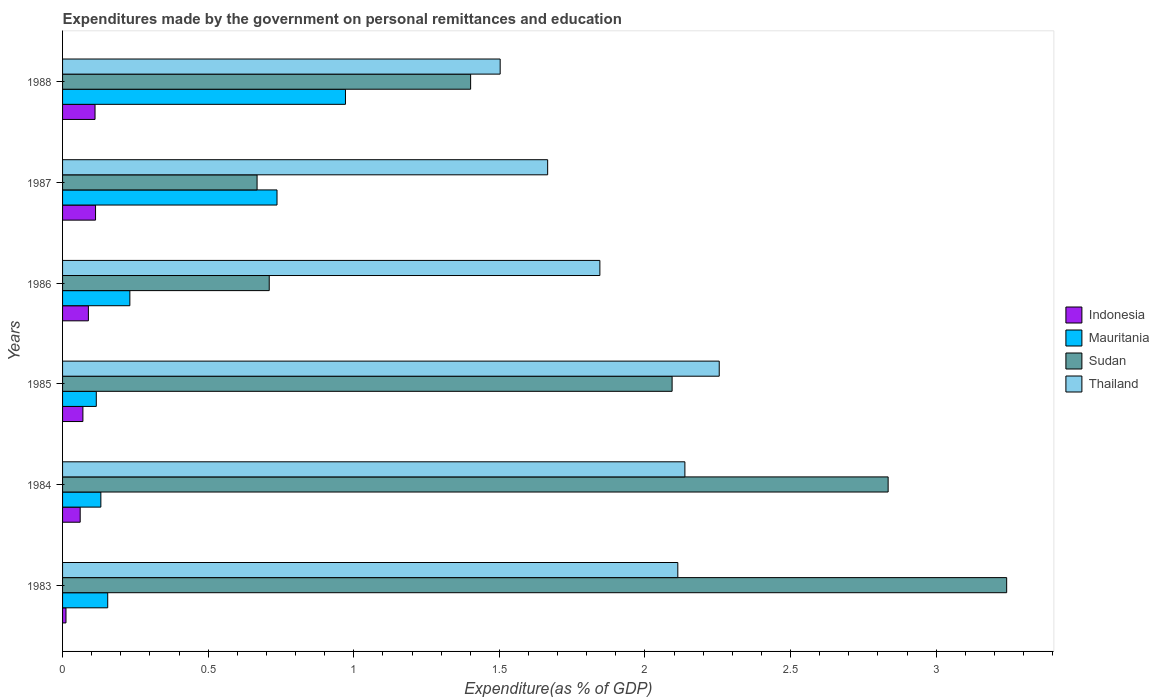How many different coloured bars are there?
Make the answer very short. 4. How many groups of bars are there?
Ensure brevity in your answer.  6. Are the number of bars on each tick of the Y-axis equal?
Your response must be concise. Yes. How many bars are there on the 6th tick from the top?
Provide a succinct answer. 4. In how many cases, is the number of bars for a given year not equal to the number of legend labels?
Give a very brief answer. 0. What is the expenditures made by the government on personal remittances and education in Indonesia in 1986?
Offer a terse response. 0.09. Across all years, what is the maximum expenditures made by the government on personal remittances and education in Indonesia?
Provide a short and direct response. 0.11. Across all years, what is the minimum expenditures made by the government on personal remittances and education in Mauritania?
Your response must be concise. 0.12. In which year was the expenditures made by the government on personal remittances and education in Indonesia maximum?
Offer a very short reply. 1987. In which year was the expenditures made by the government on personal remittances and education in Indonesia minimum?
Your response must be concise. 1983. What is the total expenditures made by the government on personal remittances and education in Sudan in the graph?
Offer a very short reply. 10.95. What is the difference between the expenditures made by the government on personal remittances and education in Mauritania in 1985 and that in 1987?
Keep it short and to the point. -0.62. What is the difference between the expenditures made by the government on personal remittances and education in Thailand in 1986 and the expenditures made by the government on personal remittances and education in Sudan in 1984?
Your response must be concise. -0.99. What is the average expenditures made by the government on personal remittances and education in Thailand per year?
Offer a terse response. 1.92. In the year 1987, what is the difference between the expenditures made by the government on personal remittances and education in Thailand and expenditures made by the government on personal remittances and education in Mauritania?
Your answer should be compact. 0.93. In how many years, is the expenditures made by the government on personal remittances and education in Thailand greater than 2.8 %?
Keep it short and to the point. 0. What is the ratio of the expenditures made by the government on personal remittances and education in Indonesia in 1984 to that in 1986?
Your response must be concise. 0.68. Is the difference between the expenditures made by the government on personal remittances and education in Thailand in 1984 and 1987 greater than the difference between the expenditures made by the government on personal remittances and education in Mauritania in 1984 and 1987?
Keep it short and to the point. Yes. What is the difference between the highest and the second highest expenditures made by the government on personal remittances and education in Thailand?
Ensure brevity in your answer.  0.12. What is the difference between the highest and the lowest expenditures made by the government on personal remittances and education in Thailand?
Provide a succinct answer. 0.75. In how many years, is the expenditures made by the government on personal remittances and education in Sudan greater than the average expenditures made by the government on personal remittances and education in Sudan taken over all years?
Offer a terse response. 3. Is the sum of the expenditures made by the government on personal remittances and education in Mauritania in 1983 and 1985 greater than the maximum expenditures made by the government on personal remittances and education in Sudan across all years?
Your answer should be compact. No. What does the 3rd bar from the top in 1988 represents?
Offer a terse response. Mauritania. What does the 4th bar from the bottom in 1983 represents?
Keep it short and to the point. Thailand. How many bars are there?
Your response must be concise. 24. Where does the legend appear in the graph?
Provide a succinct answer. Center right. What is the title of the graph?
Your response must be concise. Expenditures made by the government on personal remittances and education. Does "Central Europe" appear as one of the legend labels in the graph?
Keep it short and to the point. No. What is the label or title of the X-axis?
Your answer should be very brief. Expenditure(as % of GDP). What is the Expenditure(as % of GDP) of Indonesia in 1983?
Make the answer very short. 0.01. What is the Expenditure(as % of GDP) of Mauritania in 1983?
Your response must be concise. 0.16. What is the Expenditure(as % of GDP) in Sudan in 1983?
Ensure brevity in your answer.  3.24. What is the Expenditure(as % of GDP) of Thailand in 1983?
Make the answer very short. 2.11. What is the Expenditure(as % of GDP) in Indonesia in 1984?
Your answer should be very brief. 0.06. What is the Expenditure(as % of GDP) in Mauritania in 1984?
Keep it short and to the point. 0.13. What is the Expenditure(as % of GDP) of Sudan in 1984?
Your response must be concise. 2.84. What is the Expenditure(as % of GDP) in Thailand in 1984?
Keep it short and to the point. 2.14. What is the Expenditure(as % of GDP) in Indonesia in 1985?
Your answer should be very brief. 0.07. What is the Expenditure(as % of GDP) of Mauritania in 1985?
Your response must be concise. 0.12. What is the Expenditure(as % of GDP) in Sudan in 1985?
Your answer should be very brief. 2.09. What is the Expenditure(as % of GDP) in Thailand in 1985?
Provide a succinct answer. 2.26. What is the Expenditure(as % of GDP) in Indonesia in 1986?
Offer a very short reply. 0.09. What is the Expenditure(as % of GDP) of Mauritania in 1986?
Provide a succinct answer. 0.23. What is the Expenditure(as % of GDP) in Sudan in 1986?
Provide a succinct answer. 0.71. What is the Expenditure(as % of GDP) of Thailand in 1986?
Your response must be concise. 1.85. What is the Expenditure(as % of GDP) of Indonesia in 1987?
Offer a terse response. 0.11. What is the Expenditure(as % of GDP) of Mauritania in 1987?
Your response must be concise. 0.74. What is the Expenditure(as % of GDP) of Sudan in 1987?
Offer a terse response. 0.67. What is the Expenditure(as % of GDP) in Thailand in 1987?
Offer a terse response. 1.67. What is the Expenditure(as % of GDP) of Indonesia in 1988?
Offer a terse response. 0.11. What is the Expenditure(as % of GDP) in Mauritania in 1988?
Provide a succinct answer. 0.97. What is the Expenditure(as % of GDP) in Sudan in 1988?
Provide a succinct answer. 1.4. What is the Expenditure(as % of GDP) in Thailand in 1988?
Ensure brevity in your answer.  1.5. Across all years, what is the maximum Expenditure(as % of GDP) in Indonesia?
Ensure brevity in your answer.  0.11. Across all years, what is the maximum Expenditure(as % of GDP) of Mauritania?
Keep it short and to the point. 0.97. Across all years, what is the maximum Expenditure(as % of GDP) in Sudan?
Offer a terse response. 3.24. Across all years, what is the maximum Expenditure(as % of GDP) in Thailand?
Offer a very short reply. 2.26. Across all years, what is the minimum Expenditure(as % of GDP) of Indonesia?
Provide a short and direct response. 0.01. Across all years, what is the minimum Expenditure(as % of GDP) in Mauritania?
Make the answer very short. 0.12. Across all years, what is the minimum Expenditure(as % of GDP) of Sudan?
Give a very brief answer. 0.67. Across all years, what is the minimum Expenditure(as % of GDP) in Thailand?
Your answer should be very brief. 1.5. What is the total Expenditure(as % of GDP) of Indonesia in the graph?
Give a very brief answer. 0.46. What is the total Expenditure(as % of GDP) in Mauritania in the graph?
Offer a terse response. 2.34. What is the total Expenditure(as % of GDP) in Sudan in the graph?
Provide a succinct answer. 10.95. What is the total Expenditure(as % of GDP) of Thailand in the graph?
Provide a succinct answer. 11.52. What is the difference between the Expenditure(as % of GDP) in Indonesia in 1983 and that in 1984?
Your answer should be very brief. -0.05. What is the difference between the Expenditure(as % of GDP) of Mauritania in 1983 and that in 1984?
Give a very brief answer. 0.02. What is the difference between the Expenditure(as % of GDP) of Sudan in 1983 and that in 1984?
Keep it short and to the point. 0.41. What is the difference between the Expenditure(as % of GDP) in Thailand in 1983 and that in 1984?
Provide a short and direct response. -0.02. What is the difference between the Expenditure(as % of GDP) in Indonesia in 1983 and that in 1985?
Provide a short and direct response. -0.06. What is the difference between the Expenditure(as % of GDP) in Mauritania in 1983 and that in 1985?
Make the answer very short. 0.04. What is the difference between the Expenditure(as % of GDP) in Sudan in 1983 and that in 1985?
Your answer should be compact. 1.15. What is the difference between the Expenditure(as % of GDP) in Thailand in 1983 and that in 1985?
Your answer should be very brief. -0.14. What is the difference between the Expenditure(as % of GDP) of Indonesia in 1983 and that in 1986?
Ensure brevity in your answer.  -0.08. What is the difference between the Expenditure(as % of GDP) of Mauritania in 1983 and that in 1986?
Make the answer very short. -0.08. What is the difference between the Expenditure(as % of GDP) in Sudan in 1983 and that in 1986?
Keep it short and to the point. 2.53. What is the difference between the Expenditure(as % of GDP) of Thailand in 1983 and that in 1986?
Offer a very short reply. 0.27. What is the difference between the Expenditure(as % of GDP) in Indonesia in 1983 and that in 1987?
Offer a very short reply. -0.1. What is the difference between the Expenditure(as % of GDP) in Mauritania in 1983 and that in 1987?
Provide a short and direct response. -0.58. What is the difference between the Expenditure(as % of GDP) in Sudan in 1983 and that in 1987?
Your answer should be very brief. 2.57. What is the difference between the Expenditure(as % of GDP) of Thailand in 1983 and that in 1987?
Keep it short and to the point. 0.45. What is the difference between the Expenditure(as % of GDP) in Indonesia in 1983 and that in 1988?
Ensure brevity in your answer.  -0.1. What is the difference between the Expenditure(as % of GDP) of Mauritania in 1983 and that in 1988?
Your response must be concise. -0.82. What is the difference between the Expenditure(as % of GDP) in Sudan in 1983 and that in 1988?
Your response must be concise. 1.84. What is the difference between the Expenditure(as % of GDP) in Thailand in 1983 and that in 1988?
Provide a succinct answer. 0.61. What is the difference between the Expenditure(as % of GDP) of Indonesia in 1984 and that in 1985?
Provide a short and direct response. -0.01. What is the difference between the Expenditure(as % of GDP) of Mauritania in 1984 and that in 1985?
Your answer should be compact. 0.02. What is the difference between the Expenditure(as % of GDP) of Sudan in 1984 and that in 1985?
Make the answer very short. 0.74. What is the difference between the Expenditure(as % of GDP) of Thailand in 1984 and that in 1985?
Your response must be concise. -0.12. What is the difference between the Expenditure(as % of GDP) in Indonesia in 1984 and that in 1986?
Your response must be concise. -0.03. What is the difference between the Expenditure(as % of GDP) in Mauritania in 1984 and that in 1986?
Provide a succinct answer. -0.1. What is the difference between the Expenditure(as % of GDP) of Sudan in 1984 and that in 1986?
Ensure brevity in your answer.  2.13. What is the difference between the Expenditure(as % of GDP) in Thailand in 1984 and that in 1986?
Your response must be concise. 0.29. What is the difference between the Expenditure(as % of GDP) of Indonesia in 1984 and that in 1987?
Give a very brief answer. -0.05. What is the difference between the Expenditure(as % of GDP) in Mauritania in 1984 and that in 1987?
Provide a succinct answer. -0.6. What is the difference between the Expenditure(as % of GDP) of Sudan in 1984 and that in 1987?
Ensure brevity in your answer.  2.17. What is the difference between the Expenditure(as % of GDP) of Thailand in 1984 and that in 1987?
Provide a short and direct response. 0.47. What is the difference between the Expenditure(as % of GDP) in Indonesia in 1984 and that in 1988?
Provide a succinct answer. -0.05. What is the difference between the Expenditure(as % of GDP) of Mauritania in 1984 and that in 1988?
Provide a short and direct response. -0.84. What is the difference between the Expenditure(as % of GDP) in Sudan in 1984 and that in 1988?
Offer a terse response. 1.43. What is the difference between the Expenditure(as % of GDP) of Thailand in 1984 and that in 1988?
Offer a very short reply. 0.63. What is the difference between the Expenditure(as % of GDP) in Indonesia in 1985 and that in 1986?
Provide a short and direct response. -0.02. What is the difference between the Expenditure(as % of GDP) of Mauritania in 1985 and that in 1986?
Give a very brief answer. -0.12. What is the difference between the Expenditure(as % of GDP) of Sudan in 1985 and that in 1986?
Provide a succinct answer. 1.38. What is the difference between the Expenditure(as % of GDP) of Thailand in 1985 and that in 1986?
Keep it short and to the point. 0.41. What is the difference between the Expenditure(as % of GDP) of Indonesia in 1985 and that in 1987?
Provide a short and direct response. -0.04. What is the difference between the Expenditure(as % of GDP) in Mauritania in 1985 and that in 1987?
Offer a terse response. -0.62. What is the difference between the Expenditure(as % of GDP) of Sudan in 1985 and that in 1987?
Ensure brevity in your answer.  1.43. What is the difference between the Expenditure(as % of GDP) in Thailand in 1985 and that in 1987?
Keep it short and to the point. 0.59. What is the difference between the Expenditure(as % of GDP) of Indonesia in 1985 and that in 1988?
Your answer should be very brief. -0.04. What is the difference between the Expenditure(as % of GDP) of Mauritania in 1985 and that in 1988?
Provide a short and direct response. -0.86. What is the difference between the Expenditure(as % of GDP) in Sudan in 1985 and that in 1988?
Provide a succinct answer. 0.69. What is the difference between the Expenditure(as % of GDP) in Thailand in 1985 and that in 1988?
Your response must be concise. 0.75. What is the difference between the Expenditure(as % of GDP) in Indonesia in 1986 and that in 1987?
Ensure brevity in your answer.  -0.02. What is the difference between the Expenditure(as % of GDP) in Mauritania in 1986 and that in 1987?
Offer a very short reply. -0.51. What is the difference between the Expenditure(as % of GDP) of Sudan in 1986 and that in 1987?
Your answer should be compact. 0.04. What is the difference between the Expenditure(as % of GDP) in Thailand in 1986 and that in 1987?
Provide a succinct answer. 0.18. What is the difference between the Expenditure(as % of GDP) in Indonesia in 1986 and that in 1988?
Offer a terse response. -0.02. What is the difference between the Expenditure(as % of GDP) of Mauritania in 1986 and that in 1988?
Your answer should be very brief. -0.74. What is the difference between the Expenditure(as % of GDP) in Sudan in 1986 and that in 1988?
Your answer should be very brief. -0.69. What is the difference between the Expenditure(as % of GDP) of Thailand in 1986 and that in 1988?
Give a very brief answer. 0.34. What is the difference between the Expenditure(as % of GDP) of Indonesia in 1987 and that in 1988?
Your answer should be very brief. 0. What is the difference between the Expenditure(as % of GDP) in Mauritania in 1987 and that in 1988?
Offer a terse response. -0.24. What is the difference between the Expenditure(as % of GDP) of Sudan in 1987 and that in 1988?
Provide a succinct answer. -0.73. What is the difference between the Expenditure(as % of GDP) of Thailand in 1987 and that in 1988?
Your response must be concise. 0.16. What is the difference between the Expenditure(as % of GDP) in Indonesia in 1983 and the Expenditure(as % of GDP) in Mauritania in 1984?
Your answer should be compact. -0.12. What is the difference between the Expenditure(as % of GDP) of Indonesia in 1983 and the Expenditure(as % of GDP) of Sudan in 1984?
Make the answer very short. -2.82. What is the difference between the Expenditure(as % of GDP) in Indonesia in 1983 and the Expenditure(as % of GDP) in Thailand in 1984?
Keep it short and to the point. -2.13. What is the difference between the Expenditure(as % of GDP) of Mauritania in 1983 and the Expenditure(as % of GDP) of Sudan in 1984?
Provide a succinct answer. -2.68. What is the difference between the Expenditure(as % of GDP) in Mauritania in 1983 and the Expenditure(as % of GDP) in Thailand in 1984?
Provide a succinct answer. -1.98. What is the difference between the Expenditure(as % of GDP) of Sudan in 1983 and the Expenditure(as % of GDP) of Thailand in 1984?
Provide a short and direct response. 1.11. What is the difference between the Expenditure(as % of GDP) in Indonesia in 1983 and the Expenditure(as % of GDP) in Mauritania in 1985?
Keep it short and to the point. -0.1. What is the difference between the Expenditure(as % of GDP) of Indonesia in 1983 and the Expenditure(as % of GDP) of Sudan in 1985?
Keep it short and to the point. -2.08. What is the difference between the Expenditure(as % of GDP) of Indonesia in 1983 and the Expenditure(as % of GDP) of Thailand in 1985?
Your answer should be compact. -2.24. What is the difference between the Expenditure(as % of GDP) in Mauritania in 1983 and the Expenditure(as % of GDP) in Sudan in 1985?
Your answer should be very brief. -1.94. What is the difference between the Expenditure(as % of GDP) of Mauritania in 1983 and the Expenditure(as % of GDP) of Thailand in 1985?
Your response must be concise. -2.1. What is the difference between the Expenditure(as % of GDP) in Sudan in 1983 and the Expenditure(as % of GDP) in Thailand in 1985?
Provide a succinct answer. 0.99. What is the difference between the Expenditure(as % of GDP) in Indonesia in 1983 and the Expenditure(as % of GDP) in Mauritania in 1986?
Give a very brief answer. -0.22. What is the difference between the Expenditure(as % of GDP) of Indonesia in 1983 and the Expenditure(as % of GDP) of Sudan in 1986?
Provide a short and direct response. -0.7. What is the difference between the Expenditure(as % of GDP) of Indonesia in 1983 and the Expenditure(as % of GDP) of Thailand in 1986?
Your response must be concise. -1.83. What is the difference between the Expenditure(as % of GDP) in Mauritania in 1983 and the Expenditure(as % of GDP) in Sudan in 1986?
Ensure brevity in your answer.  -0.55. What is the difference between the Expenditure(as % of GDP) of Mauritania in 1983 and the Expenditure(as % of GDP) of Thailand in 1986?
Provide a short and direct response. -1.69. What is the difference between the Expenditure(as % of GDP) in Sudan in 1983 and the Expenditure(as % of GDP) in Thailand in 1986?
Your response must be concise. 1.4. What is the difference between the Expenditure(as % of GDP) of Indonesia in 1983 and the Expenditure(as % of GDP) of Mauritania in 1987?
Offer a terse response. -0.72. What is the difference between the Expenditure(as % of GDP) in Indonesia in 1983 and the Expenditure(as % of GDP) in Sudan in 1987?
Keep it short and to the point. -0.66. What is the difference between the Expenditure(as % of GDP) in Indonesia in 1983 and the Expenditure(as % of GDP) in Thailand in 1987?
Keep it short and to the point. -1.65. What is the difference between the Expenditure(as % of GDP) in Mauritania in 1983 and the Expenditure(as % of GDP) in Sudan in 1987?
Your answer should be very brief. -0.51. What is the difference between the Expenditure(as % of GDP) of Mauritania in 1983 and the Expenditure(as % of GDP) of Thailand in 1987?
Provide a short and direct response. -1.51. What is the difference between the Expenditure(as % of GDP) of Sudan in 1983 and the Expenditure(as % of GDP) of Thailand in 1987?
Give a very brief answer. 1.58. What is the difference between the Expenditure(as % of GDP) in Indonesia in 1983 and the Expenditure(as % of GDP) in Mauritania in 1988?
Your answer should be compact. -0.96. What is the difference between the Expenditure(as % of GDP) in Indonesia in 1983 and the Expenditure(as % of GDP) in Sudan in 1988?
Offer a very short reply. -1.39. What is the difference between the Expenditure(as % of GDP) in Indonesia in 1983 and the Expenditure(as % of GDP) in Thailand in 1988?
Offer a terse response. -1.49. What is the difference between the Expenditure(as % of GDP) in Mauritania in 1983 and the Expenditure(as % of GDP) in Sudan in 1988?
Your answer should be very brief. -1.25. What is the difference between the Expenditure(as % of GDP) of Mauritania in 1983 and the Expenditure(as % of GDP) of Thailand in 1988?
Your response must be concise. -1.35. What is the difference between the Expenditure(as % of GDP) in Sudan in 1983 and the Expenditure(as % of GDP) in Thailand in 1988?
Your response must be concise. 1.74. What is the difference between the Expenditure(as % of GDP) of Indonesia in 1984 and the Expenditure(as % of GDP) of Mauritania in 1985?
Your answer should be compact. -0.06. What is the difference between the Expenditure(as % of GDP) in Indonesia in 1984 and the Expenditure(as % of GDP) in Sudan in 1985?
Your answer should be compact. -2.03. What is the difference between the Expenditure(as % of GDP) in Indonesia in 1984 and the Expenditure(as % of GDP) in Thailand in 1985?
Provide a short and direct response. -2.19. What is the difference between the Expenditure(as % of GDP) in Mauritania in 1984 and the Expenditure(as % of GDP) in Sudan in 1985?
Give a very brief answer. -1.96. What is the difference between the Expenditure(as % of GDP) in Mauritania in 1984 and the Expenditure(as % of GDP) in Thailand in 1985?
Provide a succinct answer. -2.12. What is the difference between the Expenditure(as % of GDP) of Sudan in 1984 and the Expenditure(as % of GDP) of Thailand in 1985?
Ensure brevity in your answer.  0.58. What is the difference between the Expenditure(as % of GDP) in Indonesia in 1984 and the Expenditure(as % of GDP) in Mauritania in 1986?
Ensure brevity in your answer.  -0.17. What is the difference between the Expenditure(as % of GDP) in Indonesia in 1984 and the Expenditure(as % of GDP) in Sudan in 1986?
Provide a short and direct response. -0.65. What is the difference between the Expenditure(as % of GDP) in Indonesia in 1984 and the Expenditure(as % of GDP) in Thailand in 1986?
Offer a terse response. -1.78. What is the difference between the Expenditure(as % of GDP) of Mauritania in 1984 and the Expenditure(as % of GDP) of Sudan in 1986?
Your answer should be very brief. -0.58. What is the difference between the Expenditure(as % of GDP) of Mauritania in 1984 and the Expenditure(as % of GDP) of Thailand in 1986?
Provide a short and direct response. -1.71. What is the difference between the Expenditure(as % of GDP) in Sudan in 1984 and the Expenditure(as % of GDP) in Thailand in 1986?
Your answer should be compact. 0.99. What is the difference between the Expenditure(as % of GDP) in Indonesia in 1984 and the Expenditure(as % of GDP) in Mauritania in 1987?
Your response must be concise. -0.68. What is the difference between the Expenditure(as % of GDP) in Indonesia in 1984 and the Expenditure(as % of GDP) in Sudan in 1987?
Offer a terse response. -0.61. What is the difference between the Expenditure(as % of GDP) in Indonesia in 1984 and the Expenditure(as % of GDP) in Thailand in 1987?
Give a very brief answer. -1.61. What is the difference between the Expenditure(as % of GDP) of Mauritania in 1984 and the Expenditure(as % of GDP) of Sudan in 1987?
Ensure brevity in your answer.  -0.54. What is the difference between the Expenditure(as % of GDP) in Mauritania in 1984 and the Expenditure(as % of GDP) in Thailand in 1987?
Your response must be concise. -1.53. What is the difference between the Expenditure(as % of GDP) of Sudan in 1984 and the Expenditure(as % of GDP) of Thailand in 1987?
Ensure brevity in your answer.  1.17. What is the difference between the Expenditure(as % of GDP) in Indonesia in 1984 and the Expenditure(as % of GDP) in Mauritania in 1988?
Provide a short and direct response. -0.91. What is the difference between the Expenditure(as % of GDP) in Indonesia in 1984 and the Expenditure(as % of GDP) in Sudan in 1988?
Your answer should be compact. -1.34. What is the difference between the Expenditure(as % of GDP) in Indonesia in 1984 and the Expenditure(as % of GDP) in Thailand in 1988?
Provide a succinct answer. -1.44. What is the difference between the Expenditure(as % of GDP) in Mauritania in 1984 and the Expenditure(as % of GDP) in Sudan in 1988?
Offer a terse response. -1.27. What is the difference between the Expenditure(as % of GDP) in Mauritania in 1984 and the Expenditure(as % of GDP) in Thailand in 1988?
Make the answer very short. -1.37. What is the difference between the Expenditure(as % of GDP) in Sudan in 1984 and the Expenditure(as % of GDP) in Thailand in 1988?
Offer a very short reply. 1.33. What is the difference between the Expenditure(as % of GDP) in Indonesia in 1985 and the Expenditure(as % of GDP) in Mauritania in 1986?
Offer a terse response. -0.16. What is the difference between the Expenditure(as % of GDP) of Indonesia in 1985 and the Expenditure(as % of GDP) of Sudan in 1986?
Provide a succinct answer. -0.64. What is the difference between the Expenditure(as % of GDP) in Indonesia in 1985 and the Expenditure(as % of GDP) in Thailand in 1986?
Your answer should be very brief. -1.78. What is the difference between the Expenditure(as % of GDP) in Mauritania in 1985 and the Expenditure(as % of GDP) in Sudan in 1986?
Provide a short and direct response. -0.59. What is the difference between the Expenditure(as % of GDP) in Mauritania in 1985 and the Expenditure(as % of GDP) in Thailand in 1986?
Keep it short and to the point. -1.73. What is the difference between the Expenditure(as % of GDP) of Sudan in 1985 and the Expenditure(as % of GDP) of Thailand in 1986?
Give a very brief answer. 0.25. What is the difference between the Expenditure(as % of GDP) in Indonesia in 1985 and the Expenditure(as % of GDP) in Mauritania in 1987?
Give a very brief answer. -0.67. What is the difference between the Expenditure(as % of GDP) in Indonesia in 1985 and the Expenditure(as % of GDP) in Sudan in 1987?
Your answer should be compact. -0.6. What is the difference between the Expenditure(as % of GDP) of Indonesia in 1985 and the Expenditure(as % of GDP) of Thailand in 1987?
Provide a succinct answer. -1.6. What is the difference between the Expenditure(as % of GDP) of Mauritania in 1985 and the Expenditure(as % of GDP) of Sudan in 1987?
Keep it short and to the point. -0.55. What is the difference between the Expenditure(as % of GDP) in Mauritania in 1985 and the Expenditure(as % of GDP) in Thailand in 1987?
Your answer should be compact. -1.55. What is the difference between the Expenditure(as % of GDP) in Sudan in 1985 and the Expenditure(as % of GDP) in Thailand in 1987?
Your answer should be compact. 0.43. What is the difference between the Expenditure(as % of GDP) of Indonesia in 1985 and the Expenditure(as % of GDP) of Mauritania in 1988?
Offer a terse response. -0.9. What is the difference between the Expenditure(as % of GDP) of Indonesia in 1985 and the Expenditure(as % of GDP) of Sudan in 1988?
Provide a short and direct response. -1.33. What is the difference between the Expenditure(as % of GDP) in Indonesia in 1985 and the Expenditure(as % of GDP) in Thailand in 1988?
Offer a terse response. -1.43. What is the difference between the Expenditure(as % of GDP) in Mauritania in 1985 and the Expenditure(as % of GDP) in Sudan in 1988?
Make the answer very short. -1.29. What is the difference between the Expenditure(as % of GDP) in Mauritania in 1985 and the Expenditure(as % of GDP) in Thailand in 1988?
Ensure brevity in your answer.  -1.39. What is the difference between the Expenditure(as % of GDP) of Sudan in 1985 and the Expenditure(as % of GDP) of Thailand in 1988?
Your answer should be compact. 0.59. What is the difference between the Expenditure(as % of GDP) of Indonesia in 1986 and the Expenditure(as % of GDP) of Mauritania in 1987?
Keep it short and to the point. -0.65. What is the difference between the Expenditure(as % of GDP) of Indonesia in 1986 and the Expenditure(as % of GDP) of Sudan in 1987?
Offer a very short reply. -0.58. What is the difference between the Expenditure(as % of GDP) of Indonesia in 1986 and the Expenditure(as % of GDP) of Thailand in 1987?
Offer a very short reply. -1.58. What is the difference between the Expenditure(as % of GDP) in Mauritania in 1986 and the Expenditure(as % of GDP) in Sudan in 1987?
Provide a short and direct response. -0.44. What is the difference between the Expenditure(as % of GDP) in Mauritania in 1986 and the Expenditure(as % of GDP) in Thailand in 1987?
Your answer should be compact. -1.43. What is the difference between the Expenditure(as % of GDP) of Sudan in 1986 and the Expenditure(as % of GDP) of Thailand in 1987?
Your answer should be compact. -0.96. What is the difference between the Expenditure(as % of GDP) of Indonesia in 1986 and the Expenditure(as % of GDP) of Mauritania in 1988?
Give a very brief answer. -0.88. What is the difference between the Expenditure(as % of GDP) in Indonesia in 1986 and the Expenditure(as % of GDP) in Sudan in 1988?
Make the answer very short. -1.31. What is the difference between the Expenditure(as % of GDP) of Indonesia in 1986 and the Expenditure(as % of GDP) of Thailand in 1988?
Give a very brief answer. -1.41. What is the difference between the Expenditure(as % of GDP) of Mauritania in 1986 and the Expenditure(as % of GDP) of Sudan in 1988?
Give a very brief answer. -1.17. What is the difference between the Expenditure(as % of GDP) in Mauritania in 1986 and the Expenditure(as % of GDP) in Thailand in 1988?
Offer a terse response. -1.27. What is the difference between the Expenditure(as % of GDP) of Sudan in 1986 and the Expenditure(as % of GDP) of Thailand in 1988?
Ensure brevity in your answer.  -0.79. What is the difference between the Expenditure(as % of GDP) in Indonesia in 1987 and the Expenditure(as % of GDP) in Mauritania in 1988?
Provide a short and direct response. -0.86. What is the difference between the Expenditure(as % of GDP) in Indonesia in 1987 and the Expenditure(as % of GDP) in Sudan in 1988?
Make the answer very short. -1.29. What is the difference between the Expenditure(as % of GDP) in Indonesia in 1987 and the Expenditure(as % of GDP) in Thailand in 1988?
Provide a short and direct response. -1.39. What is the difference between the Expenditure(as % of GDP) of Mauritania in 1987 and the Expenditure(as % of GDP) of Sudan in 1988?
Your answer should be very brief. -0.66. What is the difference between the Expenditure(as % of GDP) in Mauritania in 1987 and the Expenditure(as % of GDP) in Thailand in 1988?
Your answer should be compact. -0.77. What is the difference between the Expenditure(as % of GDP) of Sudan in 1987 and the Expenditure(as % of GDP) of Thailand in 1988?
Your response must be concise. -0.83. What is the average Expenditure(as % of GDP) of Indonesia per year?
Provide a succinct answer. 0.08. What is the average Expenditure(as % of GDP) of Mauritania per year?
Provide a short and direct response. 0.39. What is the average Expenditure(as % of GDP) in Sudan per year?
Your answer should be very brief. 1.82. What is the average Expenditure(as % of GDP) in Thailand per year?
Keep it short and to the point. 1.92. In the year 1983, what is the difference between the Expenditure(as % of GDP) in Indonesia and Expenditure(as % of GDP) in Mauritania?
Offer a very short reply. -0.14. In the year 1983, what is the difference between the Expenditure(as % of GDP) in Indonesia and Expenditure(as % of GDP) in Sudan?
Keep it short and to the point. -3.23. In the year 1983, what is the difference between the Expenditure(as % of GDP) in Indonesia and Expenditure(as % of GDP) in Thailand?
Offer a very short reply. -2.1. In the year 1983, what is the difference between the Expenditure(as % of GDP) in Mauritania and Expenditure(as % of GDP) in Sudan?
Your response must be concise. -3.09. In the year 1983, what is the difference between the Expenditure(as % of GDP) in Mauritania and Expenditure(as % of GDP) in Thailand?
Keep it short and to the point. -1.96. In the year 1983, what is the difference between the Expenditure(as % of GDP) in Sudan and Expenditure(as % of GDP) in Thailand?
Make the answer very short. 1.13. In the year 1984, what is the difference between the Expenditure(as % of GDP) in Indonesia and Expenditure(as % of GDP) in Mauritania?
Your answer should be very brief. -0.07. In the year 1984, what is the difference between the Expenditure(as % of GDP) of Indonesia and Expenditure(as % of GDP) of Sudan?
Offer a very short reply. -2.77. In the year 1984, what is the difference between the Expenditure(as % of GDP) of Indonesia and Expenditure(as % of GDP) of Thailand?
Give a very brief answer. -2.08. In the year 1984, what is the difference between the Expenditure(as % of GDP) of Mauritania and Expenditure(as % of GDP) of Sudan?
Offer a very short reply. -2.7. In the year 1984, what is the difference between the Expenditure(as % of GDP) of Mauritania and Expenditure(as % of GDP) of Thailand?
Your answer should be compact. -2.01. In the year 1984, what is the difference between the Expenditure(as % of GDP) of Sudan and Expenditure(as % of GDP) of Thailand?
Your answer should be very brief. 0.7. In the year 1985, what is the difference between the Expenditure(as % of GDP) in Indonesia and Expenditure(as % of GDP) in Mauritania?
Ensure brevity in your answer.  -0.05. In the year 1985, what is the difference between the Expenditure(as % of GDP) of Indonesia and Expenditure(as % of GDP) of Sudan?
Your answer should be very brief. -2.02. In the year 1985, what is the difference between the Expenditure(as % of GDP) of Indonesia and Expenditure(as % of GDP) of Thailand?
Your answer should be very brief. -2.19. In the year 1985, what is the difference between the Expenditure(as % of GDP) of Mauritania and Expenditure(as % of GDP) of Sudan?
Offer a very short reply. -1.98. In the year 1985, what is the difference between the Expenditure(as % of GDP) in Mauritania and Expenditure(as % of GDP) in Thailand?
Your answer should be very brief. -2.14. In the year 1985, what is the difference between the Expenditure(as % of GDP) of Sudan and Expenditure(as % of GDP) of Thailand?
Make the answer very short. -0.16. In the year 1986, what is the difference between the Expenditure(as % of GDP) of Indonesia and Expenditure(as % of GDP) of Mauritania?
Keep it short and to the point. -0.14. In the year 1986, what is the difference between the Expenditure(as % of GDP) in Indonesia and Expenditure(as % of GDP) in Sudan?
Make the answer very short. -0.62. In the year 1986, what is the difference between the Expenditure(as % of GDP) in Indonesia and Expenditure(as % of GDP) in Thailand?
Give a very brief answer. -1.76. In the year 1986, what is the difference between the Expenditure(as % of GDP) in Mauritania and Expenditure(as % of GDP) in Sudan?
Offer a very short reply. -0.48. In the year 1986, what is the difference between the Expenditure(as % of GDP) in Mauritania and Expenditure(as % of GDP) in Thailand?
Ensure brevity in your answer.  -1.61. In the year 1986, what is the difference between the Expenditure(as % of GDP) in Sudan and Expenditure(as % of GDP) in Thailand?
Provide a short and direct response. -1.14. In the year 1987, what is the difference between the Expenditure(as % of GDP) of Indonesia and Expenditure(as % of GDP) of Mauritania?
Give a very brief answer. -0.62. In the year 1987, what is the difference between the Expenditure(as % of GDP) in Indonesia and Expenditure(as % of GDP) in Sudan?
Your answer should be very brief. -0.55. In the year 1987, what is the difference between the Expenditure(as % of GDP) of Indonesia and Expenditure(as % of GDP) of Thailand?
Your answer should be compact. -1.55. In the year 1987, what is the difference between the Expenditure(as % of GDP) in Mauritania and Expenditure(as % of GDP) in Sudan?
Keep it short and to the point. 0.07. In the year 1987, what is the difference between the Expenditure(as % of GDP) in Mauritania and Expenditure(as % of GDP) in Thailand?
Offer a very short reply. -0.93. In the year 1987, what is the difference between the Expenditure(as % of GDP) in Sudan and Expenditure(as % of GDP) in Thailand?
Make the answer very short. -1. In the year 1988, what is the difference between the Expenditure(as % of GDP) in Indonesia and Expenditure(as % of GDP) in Mauritania?
Give a very brief answer. -0.86. In the year 1988, what is the difference between the Expenditure(as % of GDP) in Indonesia and Expenditure(as % of GDP) in Sudan?
Ensure brevity in your answer.  -1.29. In the year 1988, what is the difference between the Expenditure(as % of GDP) in Indonesia and Expenditure(as % of GDP) in Thailand?
Offer a terse response. -1.39. In the year 1988, what is the difference between the Expenditure(as % of GDP) of Mauritania and Expenditure(as % of GDP) of Sudan?
Your response must be concise. -0.43. In the year 1988, what is the difference between the Expenditure(as % of GDP) in Mauritania and Expenditure(as % of GDP) in Thailand?
Ensure brevity in your answer.  -0.53. In the year 1988, what is the difference between the Expenditure(as % of GDP) in Sudan and Expenditure(as % of GDP) in Thailand?
Provide a short and direct response. -0.1. What is the ratio of the Expenditure(as % of GDP) of Indonesia in 1983 to that in 1984?
Offer a terse response. 0.19. What is the ratio of the Expenditure(as % of GDP) in Mauritania in 1983 to that in 1984?
Offer a very short reply. 1.18. What is the ratio of the Expenditure(as % of GDP) in Sudan in 1983 to that in 1984?
Your response must be concise. 1.14. What is the ratio of the Expenditure(as % of GDP) of Indonesia in 1983 to that in 1985?
Make the answer very short. 0.17. What is the ratio of the Expenditure(as % of GDP) of Mauritania in 1983 to that in 1985?
Offer a terse response. 1.34. What is the ratio of the Expenditure(as % of GDP) in Sudan in 1983 to that in 1985?
Offer a terse response. 1.55. What is the ratio of the Expenditure(as % of GDP) of Thailand in 1983 to that in 1985?
Your answer should be very brief. 0.94. What is the ratio of the Expenditure(as % of GDP) in Indonesia in 1983 to that in 1986?
Provide a short and direct response. 0.13. What is the ratio of the Expenditure(as % of GDP) in Mauritania in 1983 to that in 1986?
Provide a succinct answer. 0.67. What is the ratio of the Expenditure(as % of GDP) in Sudan in 1983 to that in 1986?
Your response must be concise. 4.57. What is the ratio of the Expenditure(as % of GDP) of Thailand in 1983 to that in 1986?
Give a very brief answer. 1.15. What is the ratio of the Expenditure(as % of GDP) in Indonesia in 1983 to that in 1987?
Your response must be concise. 0.1. What is the ratio of the Expenditure(as % of GDP) of Mauritania in 1983 to that in 1987?
Offer a terse response. 0.21. What is the ratio of the Expenditure(as % of GDP) of Sudan in 1983 to that in 1987?
Offer a terse response. 4.85. What is the ratio of the Expenditure(as % of GDP) of Thailand in 1983 to that in 1987?
Your response must be concise. 1.27. What is the ratio of the Expenditure(as % of GDP) of Indonesia in 1983 to that in 1988?
Keep it short and to the point. 0.11. What is the ratio of the Expenditure(as % of GDP) of Mauritania in 1983 to that in 1988?
Your answer should be very brief. 0.16. What is the ratio of the Expenditure(as % of GDP) of Sudan in 1983 to that in 1988?
Offer a very short reply. 2.31. What is the ratio of the Expenditure(as % of GDP) in Thailand in 1983 to that in 1988?
Provide a short and direct response. 1.41. What is the ratio of the Expenditure(as % of GDP) of Indonesia in 1984 to that in 1985?
Provide a succinct answer. 0.87. What is the ratio of the Expenditure(as % of GDP) in Mauritania in 1984 to that in 1985?
Provide a short and direct response. 1.14. What is the ratio of the Expenditure(as % of GDP) of Sudan in 1984 to that in 1985?
Provide a succinct answer. 1.35. What is the ratio of the Expenditure(as % of GDP) in Thailand in 1984 to that in 1985?
Keep it short and to the point. 0.95. What is the ratio of the Expenditure(as % of GDP) in Indonesia in 1984 to that in 1986?
Make the answer very short. 0.68. What is the ratio of the Expenditure(as % of GDP) of Mauritania in 1984 to that in 1986?
Offer a terse response. 0.57. What is the ratio of the Expenditure(as % of GDP) in Sudan in 1984 to that in 1986?
Give a very brief answer. 3.99. What is the ratio of the Expenditure(as % of GDP) in Thailand in 1984 to that in 1986?
Your answer should be very brief. 1.16. What is the ratio of the Expenditure(as % of GDP) in Indonesia in 1984 to that in 1987?
Provide a succinct answer. 0.53. What is the ratio of the Expenditure(as % of GDP) in Mauritania in 1984 to that in 1987?
Give a very brief answer. 0.18. What is the ratio of the Expenditure(as % of GDP) of Sudan in 1984 to that in 1987?
Ensure brevity in your answer.  4.24. What is the ratio of the Expenditure(as % of GDP) in Thailand in 1984 to that in 1987?
Offer a terse response. 1.28. What is the ratio of the Expenditure(as % of GDP) of Indonesia in 1984 to that in 1988?
Keep it short and to the point. 0.54. What is the ratio of the Expenditure(as % of GDP) in Mauritania in 1984 to that in 1988?
Provide a short and direct response. 0.14. What is the ratio of the Expenditure(as % of GDP) of Sudan in 1984 to that in 1988?
Your response must be concise. 2.02. What is the ratio of the Expenditure(as % of GDP) in Thailand in 1984 to that in 1988?
Give a very brief answer. 1.42. What is the ratio of the Expenditure(as % of GDP) in Indonesia in 1985 to that in 1986?
Provide a succinct answer. 0.79. What is the ratio of the Expenditure(as % of GDP) in Mauritania in 1985 to that in 1986?
Offer a very short reply. 0.5. What is the ratio of the Expenditure(as % of GDP) of Sudan in 1985 to that in 1986?
Your response must be concise. 2.95. What is the ratio of the Expenditure(as % of GDP) in Thailand in 1985 to that in 1986?
Offer a terse response. 1.22. What is the ratio of the Expenditure(as % of GDP) of Indonesia in 1985 to that in 1987?
Ensure brevity in your answer.  0.62. What is the ratio of the Expenditure(as % of GDP) of Mauritania in 1985 to that in 1987?
Offer a terse response. 0.16. What is the ratio of the Expenditure(as % of GDP) in Sudan in 1985 to that in 1987?
Provide a short and direct response. 3.13. What is the ratio of the Expenditure(as % of GDP) in Thailand in 1985 to that in 1987?
Make the answer very short. 1.35. What is the ratio of the Expenditure(as % of GDP) in Indonesia in 1985 to that in 1988?
Your answer should be very brief. 0.63. What is the ratio of the Expenditure(as % of GDP) in Mauritania in 1985 to that in 1988?
Your answer should be very brief. 0.12. What is the ratio of the Expenditure(as % of GDP) of Sudan in 1985 to that in 1988?
Offer a terse response. 1.49. What is the ratio of the Expenditure(as % of GDP) of Thailand in 1985 to that in 1988?
Your answer should be compact. 1.5. What is the ratio of the Expenditure(as % of GDP) in Indonesia in 1986 to that in 1987?
Provide a short and direct response. 0.78. What is the ratio of the Expenditure(as % of GDP) of Mauritania in 1986 to that in 1987?
Provide a succinct answer. 0.31. What is the ratio of the Expenditure(as % of GDP) of Thailand in 1986 to that in 1987?
Ensure brevity in your answer.  1.11. What is the ratio of the Expenditure(as % of GDP) of Indonesia in 1986 to that in 1988?
Your response must be concise. 0.8. What is the ratio of the Expenditure(as % of GDP) of Mauritania in 1986 to that in 1988?
Provide a succinct answer. 0.24. What is the ratio of the Expenditure(as % of GDP) in Sudan in 1986 to that in 1988?
Your answer should be very brief. 0.51. What is the ratio of the Expenditure(as % of GDP) of Thailand in 1986 to that in 1988?
Give a very brief answer. 1.23. What is the ratio of the Expenditure(as % of GDP) of Indonesia in 1987 to that in 1988?
Make the answer very short. 1.02. What is the ratio of the Expenditure(as % of GDP) of Mauritania in 1987 to that in 1988?
Offer a very short reply. 0.76. What is the ratio of the Expenditure(as % of GDP) of Sudan in 1987 to that in 1988?
Your answer should be very brief. 0.48. What is the ratio of the Expenditure(as % of GDP) of Thailand in 1987 to that in 1988?
Your answer should be compact. 1.11. What is the difference between the highest and the second highest Expenditure(as % of GDP) in Indonesia?
Make the answer very short. 0. What is the difference between the highest and the second highest Expenditure(as % of GDP) in Mauritania?
Give a very brief answer. 0.24. What is the difference between the highest and the second highest Expenditure(as % of GDP) of Sudan?
Your answer should be very brief. 0.41. What is the difference between the highest and the second highest Expenditure(as % of GDP) in Thailand?
Give a very brief answer. 0.12. What is the difference between the highest and the lowest Expenditure(as % of GDP) in Indonesia?
Ensure brevity in your answer.  0.1. What is the difference between the highest and the lowest Expenditure(as % of GDP) in Mauritania?
Provide a short and direct response. 0.86. What is the difference between the highest and the lowest Expenditure(as % of GDP) of Sudan?
Offer a terse response. 2.57. What is the difference between the highest and the lowest Expenditure(as % of GDP) of Thailand?
Your response must be concise. 0.75. 